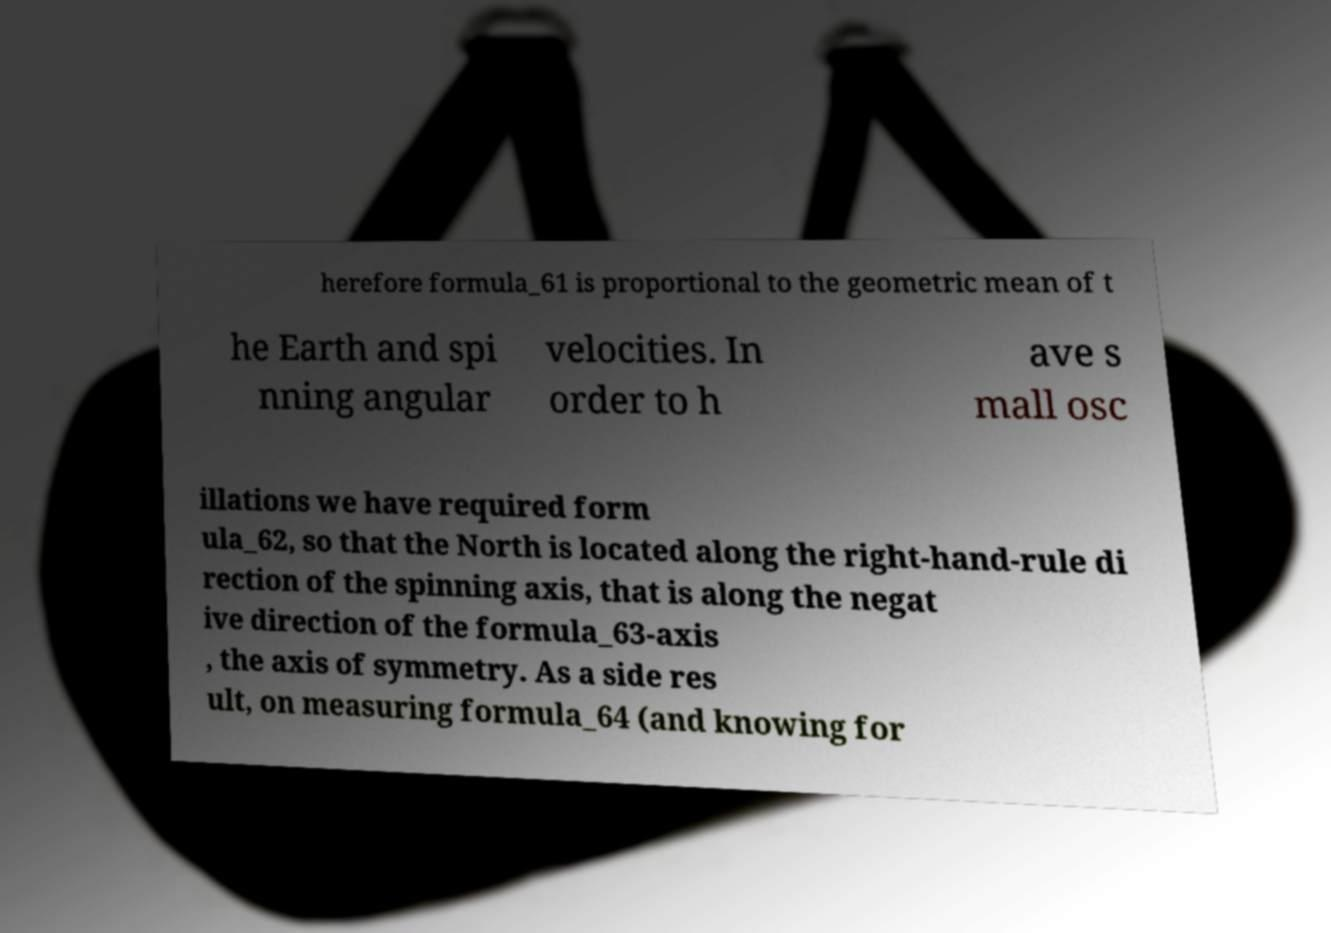Please read and relay the text visible in this image. What does it say? herefore formula_61 is proportional to the geometric mean of t he Earth and spi nning angular velocities. In order to h ave s mall osc illations we have required form ula_62, so that the North is located along the right-hand-rule di rection of the spinning axis, that is along the negat ive direction of the formula_63-axis , the axis of symmetry. As a side res ult, on measuring formula_64 (and knowing for 